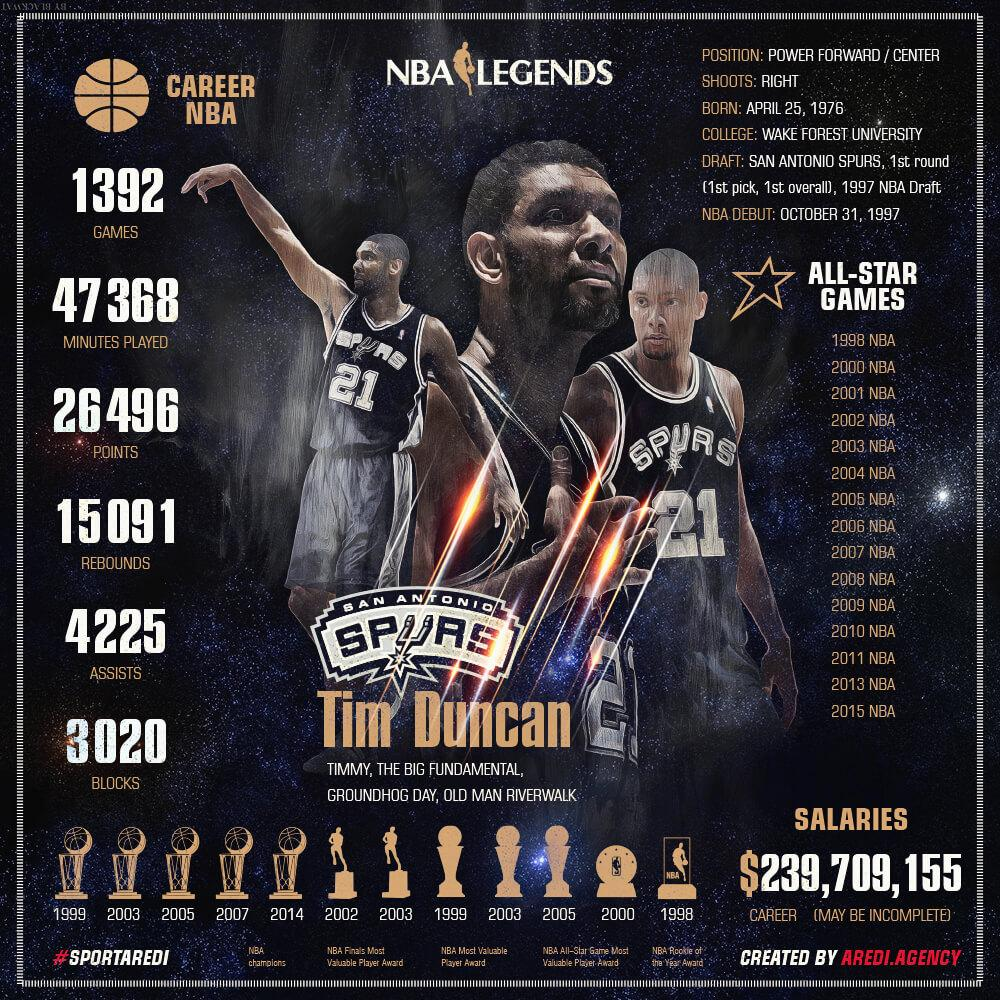Give some essential details in this illustration. Tim Duncan was awarded the NBA Rookie of the Year award in 1998. The number on the T-shirt is 21. The player won the NBA Most Valuable Player award two times. He has scored an impressive 26,496 points. He won five NBA championships. 